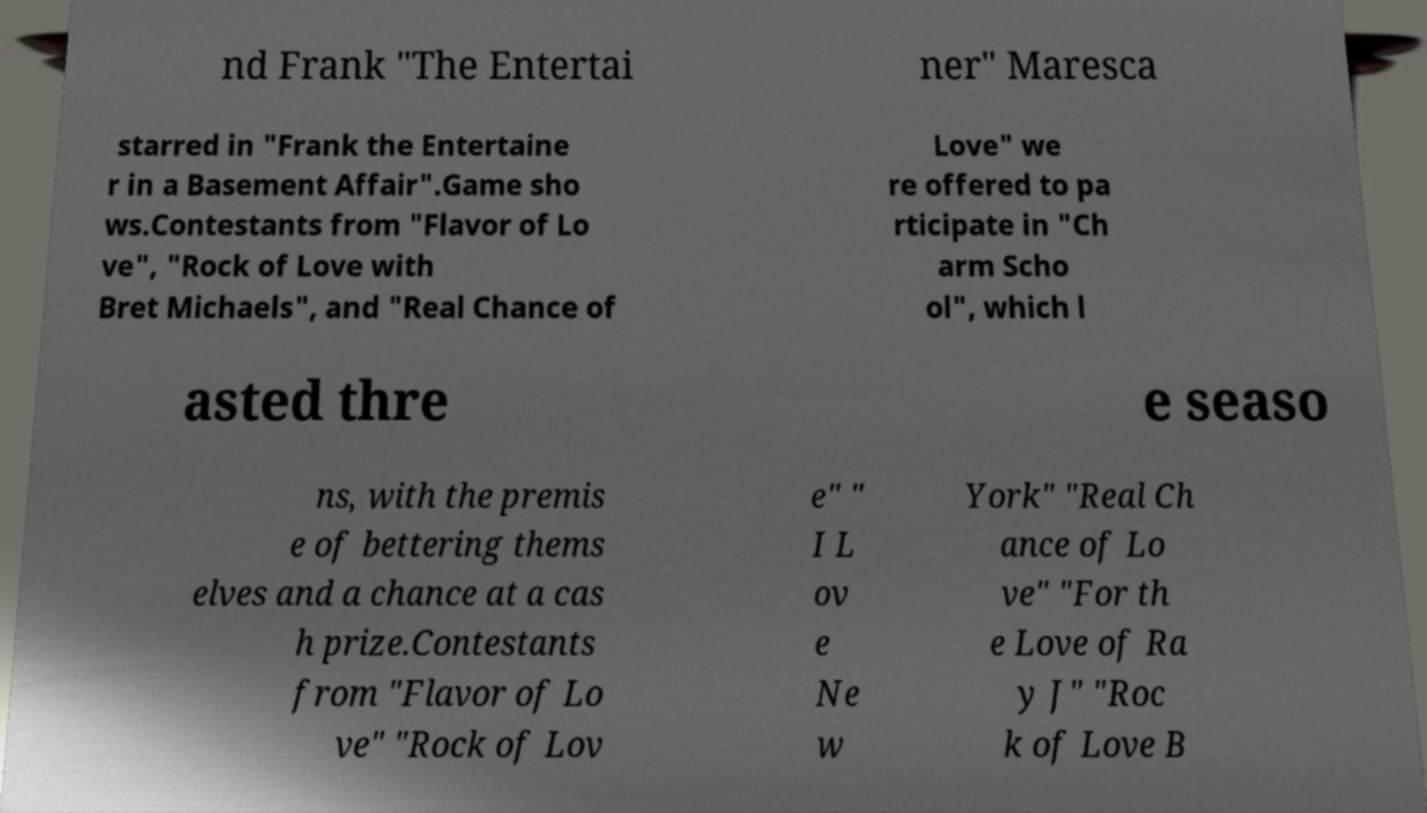What messages or text are displayed in this image? I need them in a readable, typed format. nd Frank "The Entertai ner" Maresca starred in "Frank the Entertaine r in a Basement Affair".Game sho ws.Contestants from "Flavor of Lo ve", "Rock of Love with Bret Michaels", and "Real Chance of Love" we re offered to pa rticipate in "Ch arm Scho ol", which l asted thre e seaso ns, with the premis e of bettering thems elves and a chance at a cas h prize.Contestants from "Flavor of Lo ve" "Rock of Lov e" " I L ov e Ne w York" "Real Ch ance of Lo ve" "For th e Love of Ra y J" "Roc k of Love B 